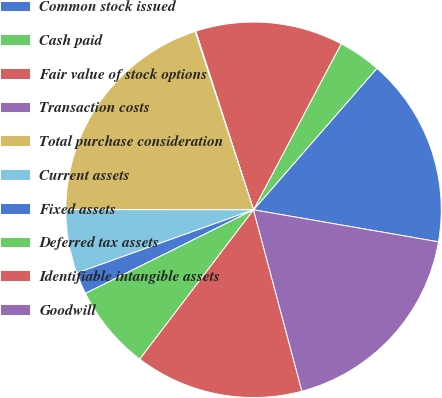<chart> <loc_0><loc_0><loc_500><loc_500><pie_chart><fcel>Common stock issued<fcel>Cash paid<fcel>Fair value of stock options<fcel>Transaction costs<fcel>Total purchase consideration<fcel>Current assets<fcel>Fixed assets<fcel>Deferred tax assets<fcel>Identifiable intangible assets<fcel>Goodwill<nl><fcel>16.32%<fcel>3.68%<fcel>12.71%<fcel>0.07%<fcel>19.93%<fcel>5.49%<fcel>1.88%<fcel>7.29%<fcel>14.51%<fcel>18.12%<nl></chart> 